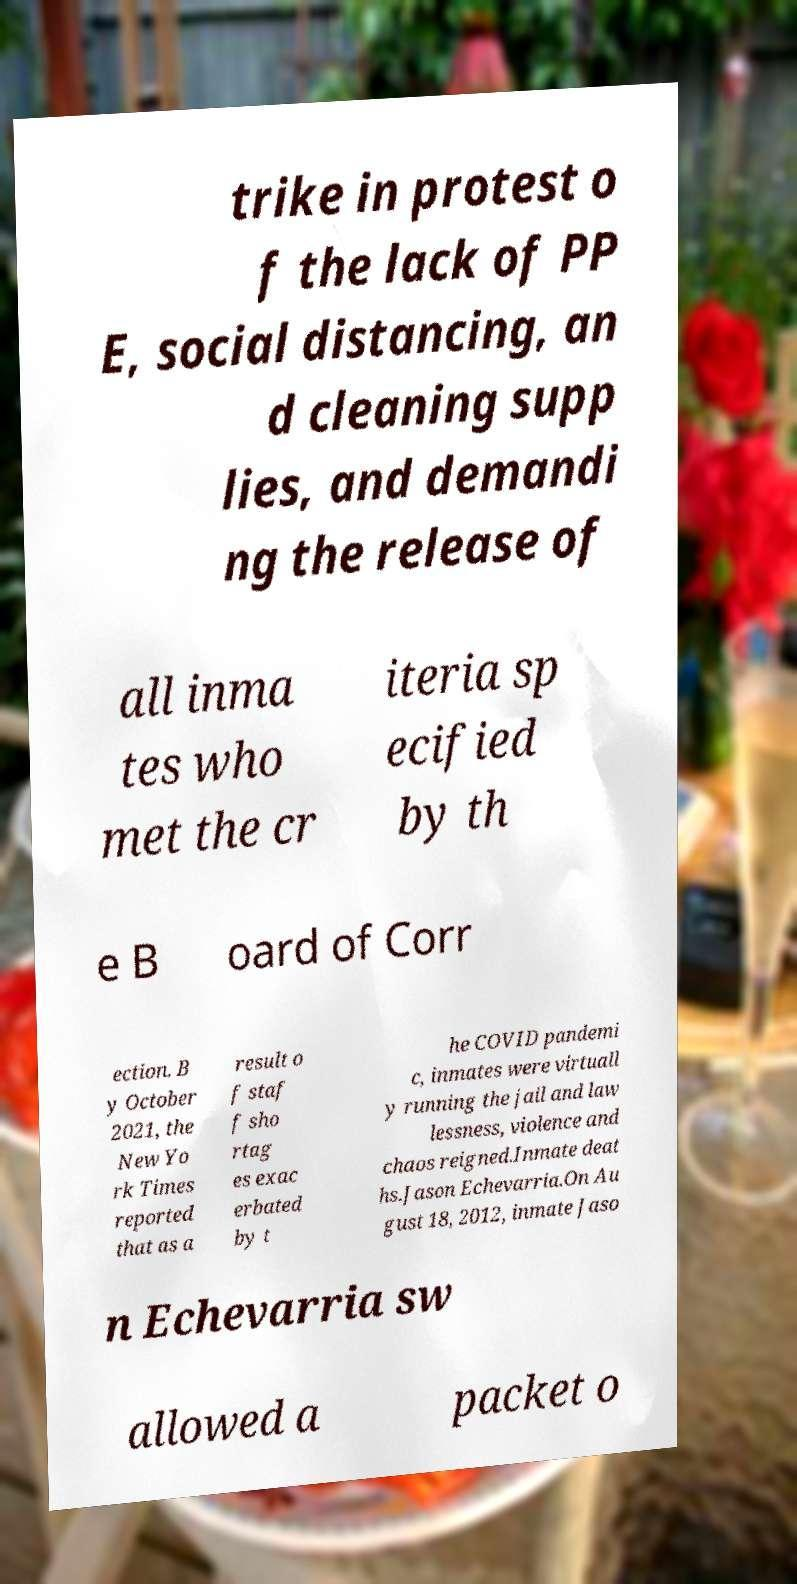Please read and relay the text visible in this image. What does it say? trike in protest o f the lack of PP E, social distancing, an d cleaning supp lies, and demandi ng the release of all inma tes who met the cr iteria sp ecified by th e B oard of Corr ection. B y October 2021, the New Yo rk Times reported that as a result o f staf f sho rtag es exac erbated by t he COVID pandemi c, inmates were virtuall y running the jail and law lessness, violence and chaos reigned.Inmate deat hs.Jason Echevarria.On Au gust 18, 2012, inmate Jaso n Echevarria sw allowed a packet o 